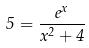<formula> <loc_0><loc_0><loc_500><loc_500>5 = \frac { e ^ { x } } { x ^ { 2 } + 4 }</formula> 